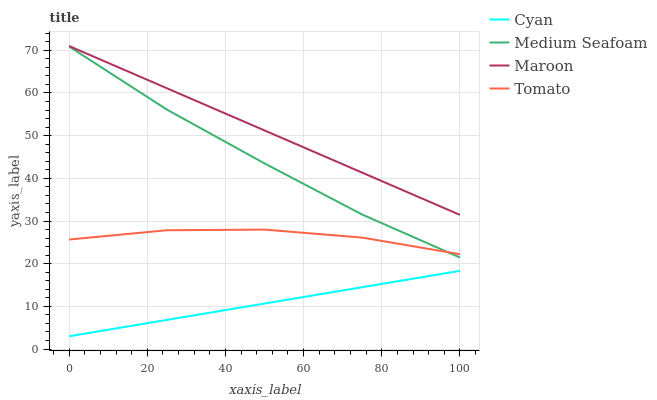Does Cyan have the minimum area under the curve?
Answer yes or no. Yes. Does Maroon have the maximum area under the curve?
Answer yes or no. Yes. Does Medium Seafoam have the minimum area under the curve?
Answer yes or no. No. Does Medium Seafoam have the maximum area under the curve?
Answer yes or no. No. Is Cyan the smoothest?
Answer yes or no. Yes. Is Tomato the roughest?
Answer yes or no. Yes. Is Medium Seafoam the smoothest?
Answer yes or no. No. Is Medium Seafoam the roughest?
Answer yes or no. No. Does Cyan have the lowest value?
Answer yes or no. Yes. Does Medium Seafoam have the lowest value?
Answer yes or no. No. Does Maroon have the highest value?
Answer yes or no. Yes. Does Medium Seafoam have the highest value?
Answer yes or no. No. Is Cyan less than Tomato?
Answer yes or no. Yes. Is Maroon greater than Tomato?
Answer yes or no. Yes. Does Tomato intersect Medium Seafoam?
Answer yes or no. Yes. Is Tomato less than Medium Seafoam?
Answer yes or no. No. Is Tomato greater than Medium Seafoam?
Answer yes or no. No. Does Cyan intersect Tomato?
Answer yes or no. No. 